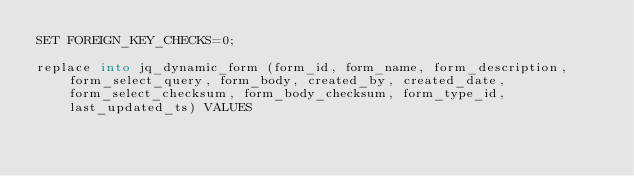Convert code to text. <code><loc_0><loc_0><loc_500><loc_500><_SQL_>SET FOREIGN_KEY_CHECKS=0;

replace into jq_dynamic_form (form_id, form_name, form_description, form_select_query, form_body, created_by, created_date, form_select_checksum, form_body_checksum, form_type_id, last_updated_ts) VALUES</code> 